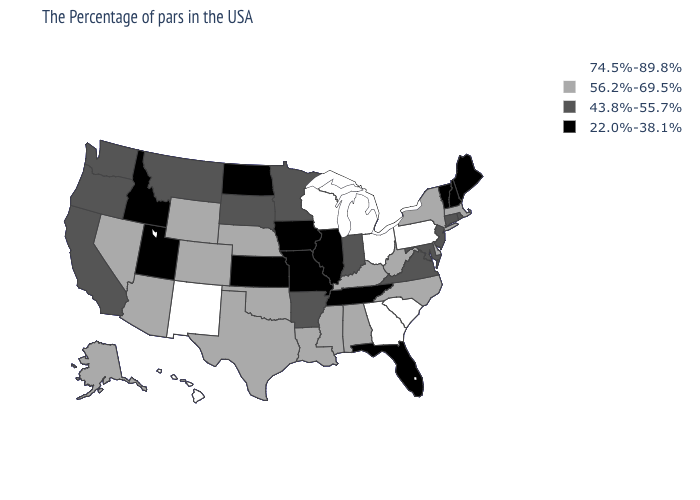Name the states that have a value in the range 74.5%-89.8%?
Keep it brief. Pennsylvania, South Carolina, Ohio, Georgia, Michigan, Wisconsin, New Mexico, Hawaii. How many symbols are there in the legend?
Short answer required. 4. What is the value of Florida?
Be succinct. 22.0%-38.1%. What is the value of Nebraska?
Concise answer only. 56.2%-69.5%. What is the value of Iowa?
Concise answer only. 22.0%-38.1%. Name the states that have a value in the range 56.2%-69.5%?
Answer briefly. Massachusetts, New York, Delaware, North Carolina, West Virginia, Kentucky, Alabama, Mississippi, Louisiana, Nebraska, Oklahoma, Texas, Wyoming, Colorado, Arizona, Nevada, Alaska. Does Idaho have the highest value in the USA?
Short answer required. No. What is the value of Georgia?
Concise answer only. 74.5%-89.8%. What is the value of Hawaii?
Be succinct. 74.5%-89.8%. What is the highest value in the South ?
Answer briefly. 74.5%-89.8%. What is the value of Oregon?
Short answer required. 43.8%-55.7%. Is the legend a continuous bar?
Answer briefly. No. Name the states that have a value in the range 74.5%-89.8%?
Answer briefly. Pennsylvania, South Carolina, Ohio, Georgia, Michigan, Wisconsin, New Mexico, Hawaii. Name the states that have a value in the range 22.0%-38.1%?
Short answer required. Maine, New Hampshire, Vermont, Florida, Tennessee, Illinois, Missouri, Iowa, Kansas, North Dakota, Utah, Idaho. Among the states that border Washington , which have the lowest value?
Short answer required. Idaho. 